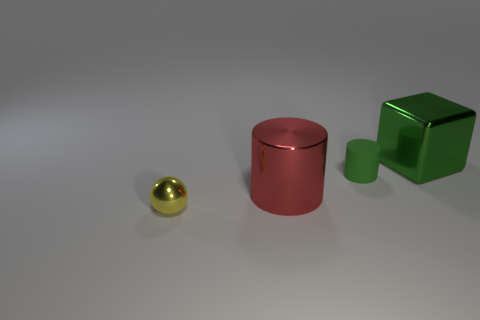What time of day does the lighting in this image suggest? Based on the soft shadows and the even distribution of light, the lighting suggests an interior scene illuminated by artificial light sources. There's no indication of a specific time of day as there are no windows or natural light sources present in the image. 